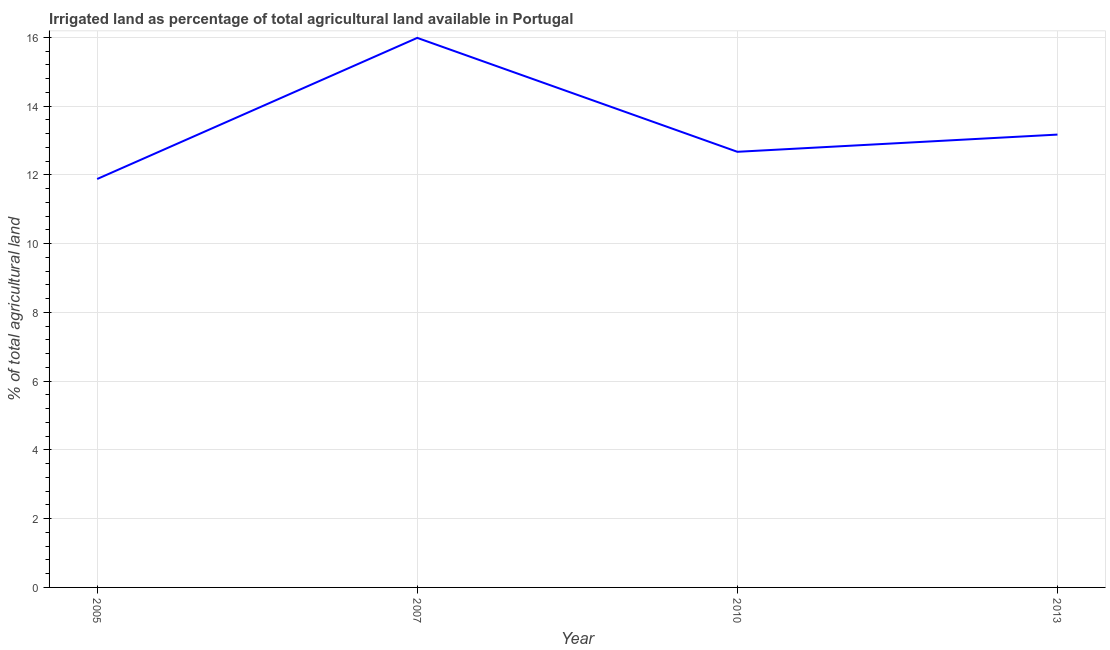What is the percentage of agricultural irrigated land in 2013?
Your answer should be very brief. 13.17. Across all years, what is the maximum percentage of agricultural irrigated land?
Provide a short and direct response. 15.99. Across all years, what is the minimum percentage of agricultural irrigated land?
Provide a succinct answer. 11.88. In which year was the percentage of agricultural irrigated land maximum?
Your response must be concise. 2007. In which year was the percentage of agricultural irrigated land minimum?
Your response must be concise. 2005. What is the sum of the percentage of agricultural irrigated land?
Your answer should be compact. 53.72. What is the difference between the percentage of agricultural irrigated land in 2005 and 2010?
Provide a succinct answer. -0.79. What is the average percentage of agricultural irrigated land per year?
Offer a very short reply. 13.43. What is the median percentage of agricultural irrigated land?
Make the answer very short. 12.92. In how many years, is the percentage of agricultural irrigated land greater than 12 %?
Ensure brevity in your answer.  3. What is the ratio of the percentage of agricultural irrigated land in 2007 to that in 2013?
Your response must be concise. 1.21. Is the difference between the percentage of agricultural irrigated land in 2007 and 2013 greater than the difference between any two years?
Offer a terse response. No. What is the difference between the highest and the second highest percentage of agricultural irrigated land?
Keep it short and to the point. 2.81. What is the difference between the highest and the lowest percentage of agricultural irrigated land?
Your response must be concise. 4.11. Does the percentage of agricultural irrigated land monotonically increase over the years?
Your answer should be compact. No. Does the graph contain grids?
Offer a very short reply. Yes. What is the title of the graph?
Provide a short and direct response. Irrigated land as percentage of total agricultural land available in Portugal. What is the label or title of the X-axis?
Provide a short and direct response. Year. What is the label or title of the Y-axis?
Provide a short and direct response. % of total agricultural land. What is the % of total agricultural land of 2005?
Ensure brevity in your answer.  11.88. What is the % of total agricultural land of 2007?
Offer a very short reply. 15.99. What is the % of total agricultural land of 2010?
Provide a short and direct response. 12.67. What is the % of total agricultural land in 2013?
Give a very brief answer. 13.17. What is the difference between the % of total agricultural land in 2005 and 2007?
Ensure brevity in your answer.  -4.11. What is the difference between the % of total agricultural land in 2005 and 2010?
Ensure brevity in your answer.  -0.79. What is the difference between the % of total agricultural land in 2005 and 2013?
Offer a very short reply. -1.29. What is the difference between the % of total agricultural land in 2007 and 2010?
Your answer should be compact. 3.31. What is the difference between the % of total agricultural land in 2007 and 2013?
Offer a very short reply. 2.81. What is the difference between the % of total agricultural land in 2010 and 2013?
Keep it short and to the point. -0.5. What is the ratio of the % of total agricultural land in 2005 to that in 2007?
Give a very brief answer. 0.74. What is the ratio of the % of total agricultural land in 2005 to that in 2010?
Your response must be concise. 0.94. What is the ratio of the % of total agricultural land in 2005 to that in 2013?
Ensure brevity in your answer.  0.9. What is the ratio of the % of total agricultural land in 2007 to that in 2010?
Offer a very short reply. 1.26. What is the ratio of the % of total agricultural land in 2007 to that in 2013?
Offer a very short reply. 1.21. 